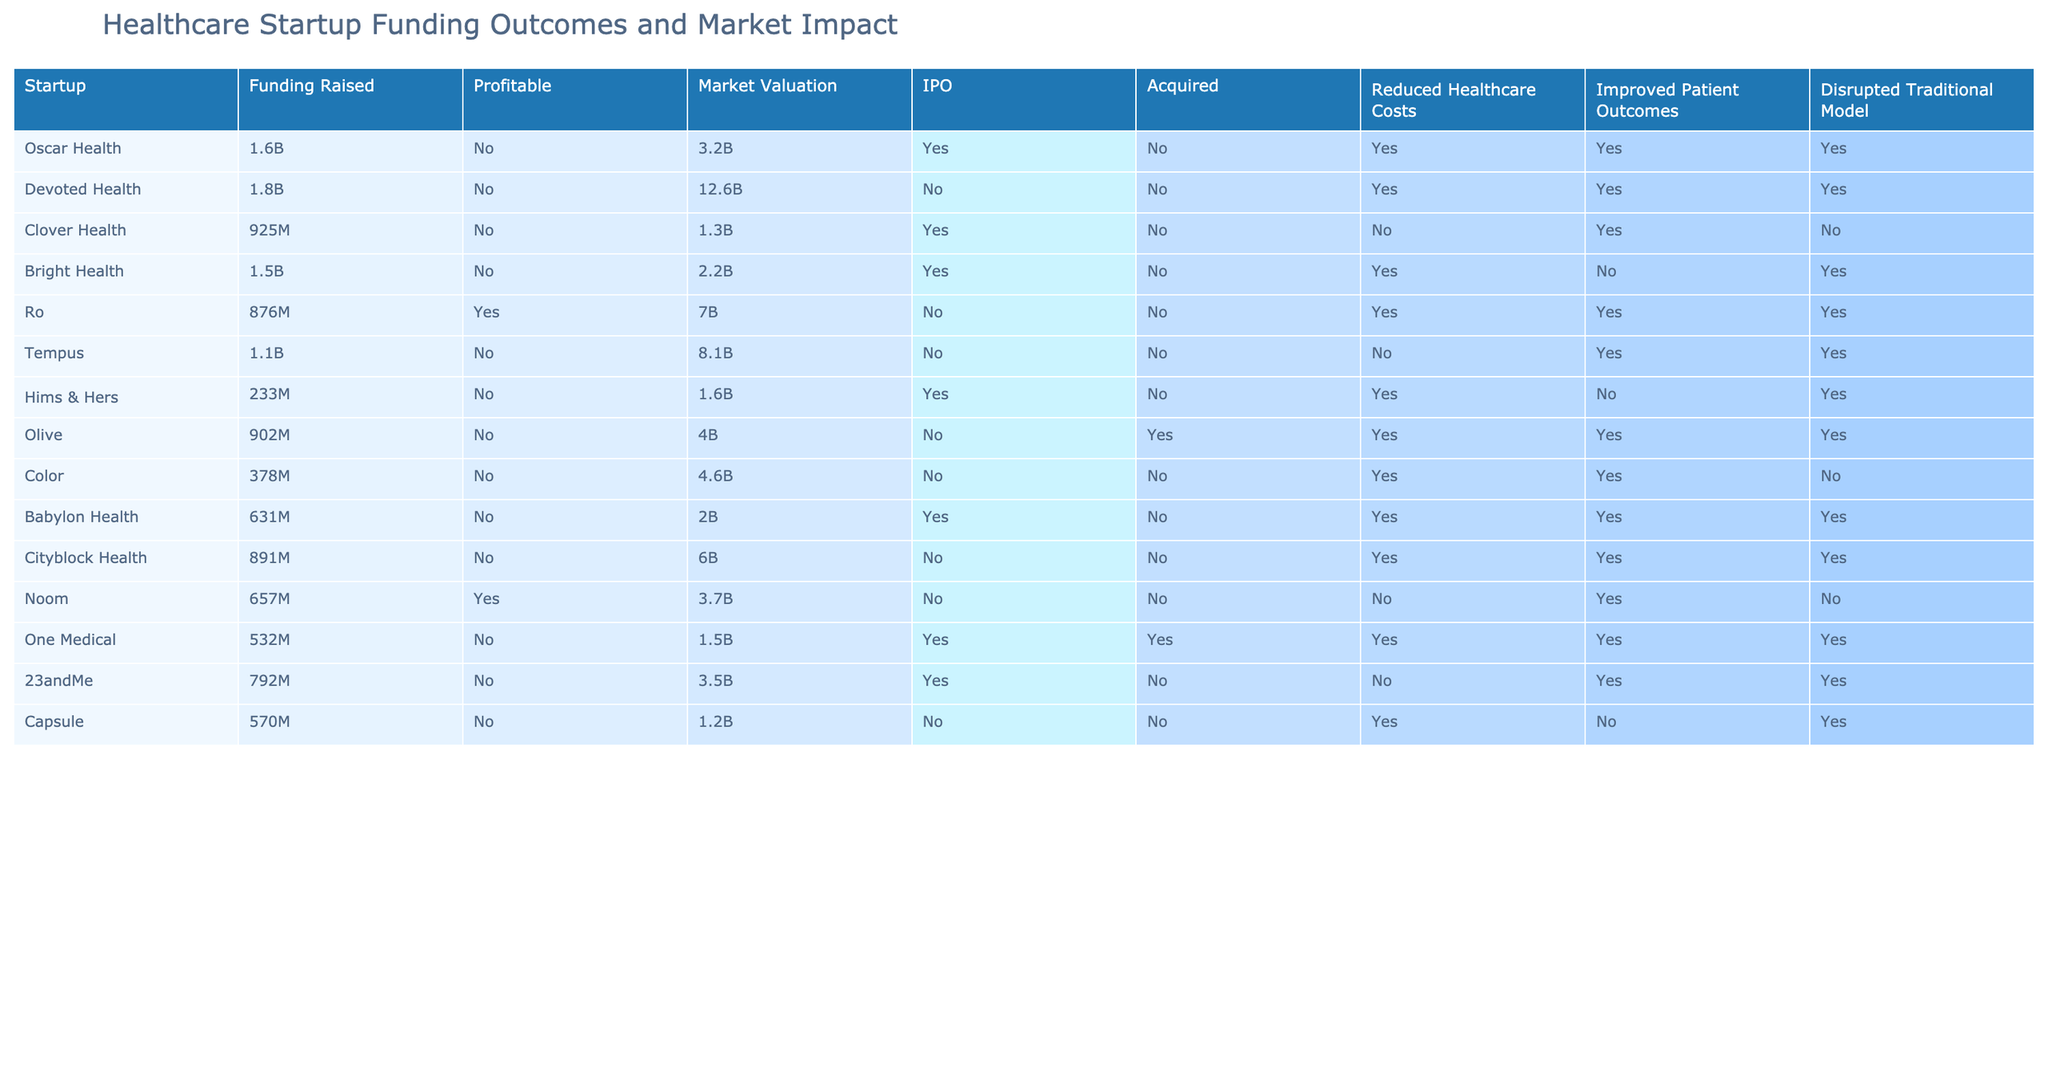What is the market valuation of Ro? According to the table, the market valuation of Ro is listed as $7B.
Answer: $7B How many startups are profitable in this table? By examining the "Profitable" column, only Ro and Noom are marked as "Yes," so there are 2 profitable startups.
Answer: 2 What is the total funding raised by startups that have been acquired? The startups that have been acquired are Olive ($902M) and One Medical ($532M). Adding these amounts gives us $902M + $532M = $1434M.
Answer: $1434M Is Oscar Health acquired by another company? The table indicates that Oscar Health has "No" under the "Acquired" column, meaning it has not been acquired.
Answer: No Which startup has the highest market valuation? By comparing the "Market Valuation" column, Devoted Health has the highest valuation at $12.6B.
Answer: $12.6B Do any startups have a profitable status while also claiming to have disrupted the traditional model? Looking at the columns "Profitable" and "Disrupted Traditional Model," Ro and Noom are marked as profitable and both have "Yes" under disrupted, indicating they both fulfill this condition.
Answer: Yes What is the total market valuation of startups that have improved patient outcomes? The startups with improved patient outcomes are Ro ($7B), Tempus ($8.1B), One Medical ($1.5B), 23andMe ($3.5B), and Babylon Health ($2B). Adding these gives $7B + $8.1B + $1.5B + $3.5B + $2B = $22.1B.
Answer: $22.1B Is there any startup that has gone public (IPO) and is also profitable? Examining the "IPO" and "Profitable" columns, Ro and One Medical are profitable, but both of them also have "Yes" under IPO, which indicates they meet the criteria of being both profitable and having gone public.
Answer: Yes What percentage of startups has reduced healthcare costs among those that are not profitable? From the table, the startups that are not profitable and have reduced healthcare costs are Oscar Health, Devoted Health, Clover Health, Bright Health, Tempus, Hims & Hers, Olive, Color, Babylon Health, Cityblock Health, and Capsule. That sums up to 11 startups out of 13 total startups. Thus, the percentage is (11/13) * 100 = 84.6%.
Answer: 84.6% 